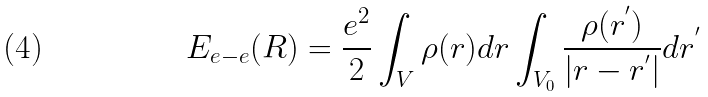Convert formula to latex. <formula><loc_0><loc_0><loc_500><loc_500>E _ { e - e } ( { R } ) = \frac { e ^ { 2 } } { 2 } \int _ { V } \rho ( { r } ) d { r } \int _ { V _ { 0 } } \frac { \rho ( { r } ^ { ^ { \prime } } ) } { | { r } - { r } ^ { ^ { \prime } } | } d { r } ^ { ^ { \prime } }</formula> 